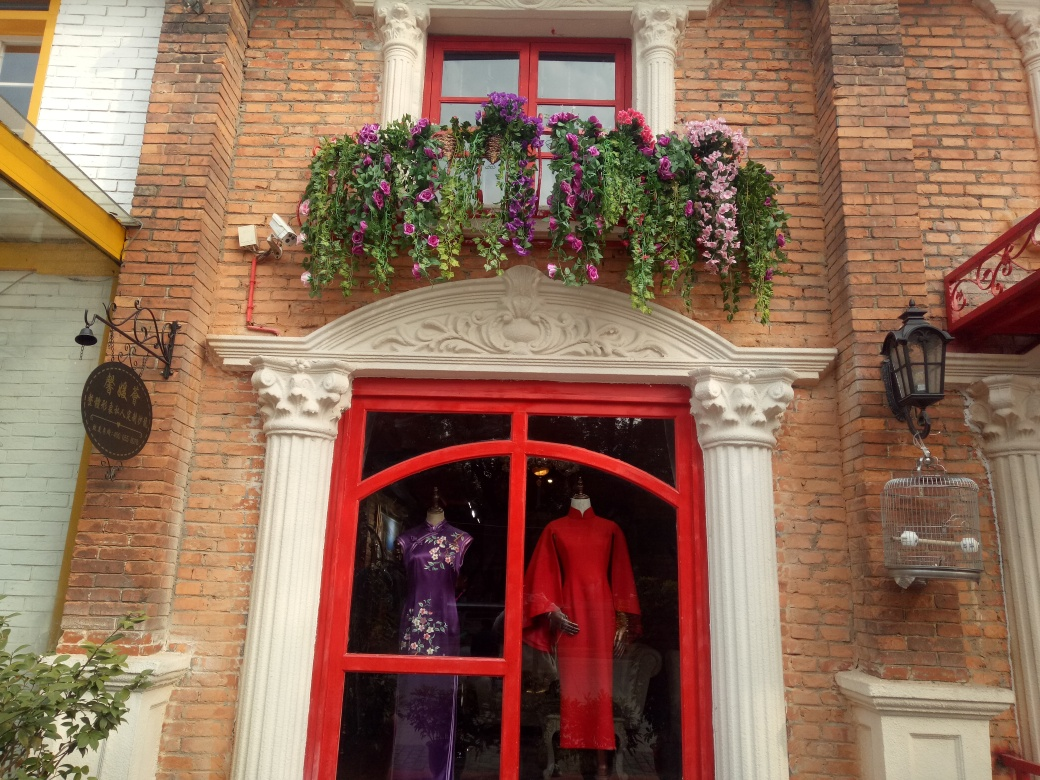Can you describe the style of the architecture? The architecture in the image seems to showcase a mix of traditional and quaint styles. The exposed brickwork and decorative elements like the white classical columns and ornate trim above the windows suggest a refined aesthetic. The combination of the vibrant colors and the older, perhaps historic, design of the building exudes charm and character. Does the style of the clothing in the shop window match the architecture? Interestingly, the clothing in the shop window presents a contrast to the architectural style. While the building exudes a historical and timeless appeal, the garments appear modern and fashionable, suggesting that the shop offers contemporary selections amidst a classic setting, which could be indicative of a blend of the old and the new. 